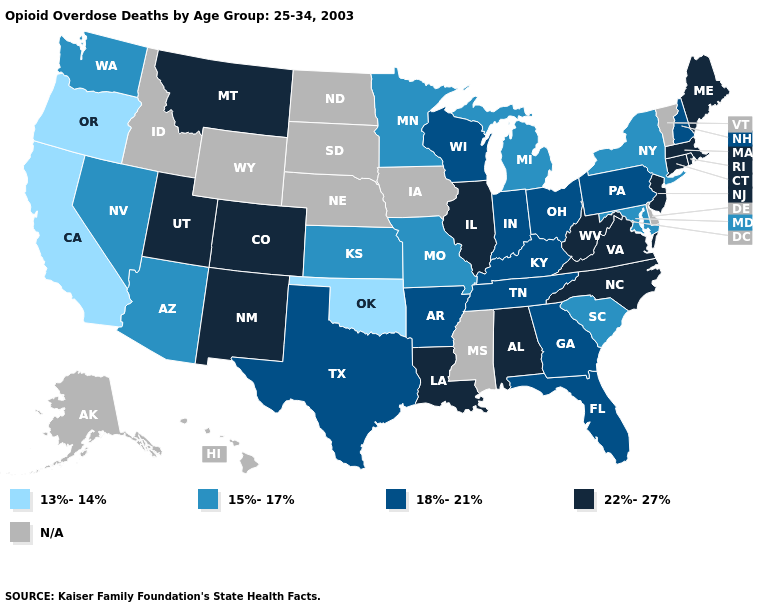What is the value of North Carolina?
Give a very brief answer. 22%-27%. Which states have the lowest value in the USA?
Be succinct. California, Oklahoma, Oregon. Among the states that border Texas , which have the highest value?
Quick response, please. Louisiana, New Mexico. Among the states that border Alabama , which have the highest value?
Short answer required. Florida, Georgia, Tennessee. Name the states that have a value in the range N/A?
Keep it brief. Alaska, Delaware, Hawaii, Idaho, Iowa, Mississippi, Nebraska, North Dakota, South Dakota, Vermont, Wyoming. What is the highest value in states that border Tennessee?
Give a very brief answer. 22%-27%. What is the value of Mississippi?
Quick response, please. N/A. How many symbols are there in the legend?
Answer briefly. 5. Does Illinois have the highest value in the MidWest?
Be succinct. Yes. What is the value of Washington?
Concise answer only. 15%-17%. Does the first symbol in the legend represent the smallest category?
Be succinct. Yes. What is the value of Indiana?
Write a very short answer. 18%-21%. What is the value of Oregon?
Concise answer only. 13%-14%. Does Oklahoma have the lowest value in the USA?
Write a very short answer. Yes. Name the states that have a value in the range 18%-21%?
Quick response, please. Arkansas, Florida, Georgia, Indiana, Kentucky, New Hampshire, Ohio, Pennsylvania, Tennessee, Texas, Wisconsin. 